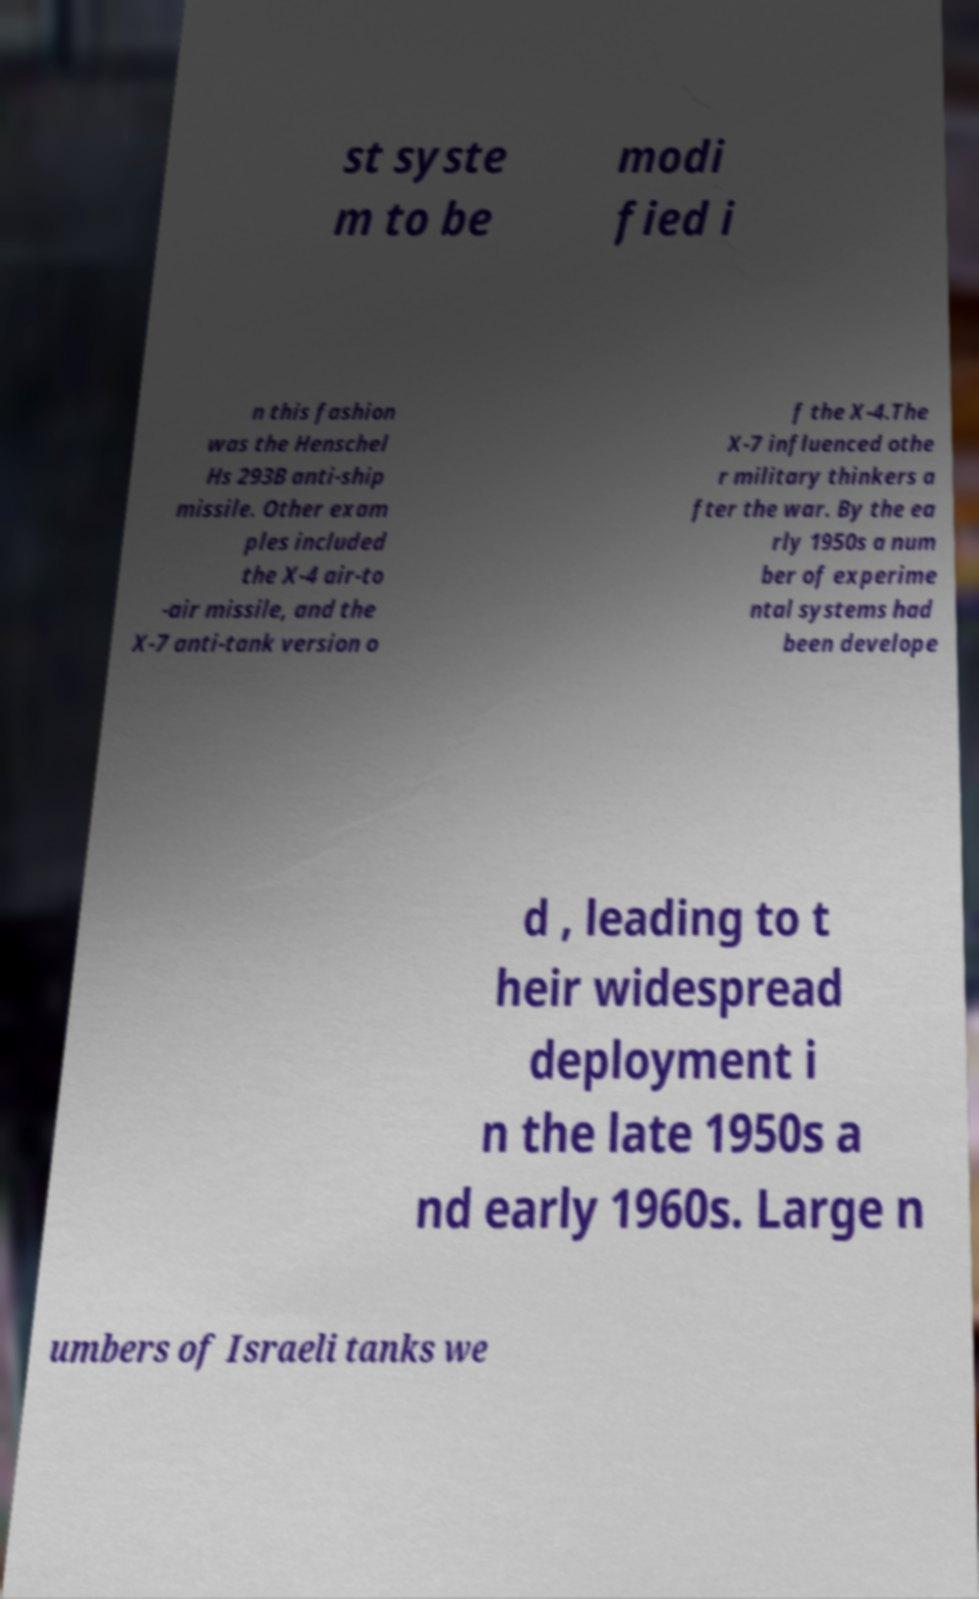Please identify and transcribe the text found in this image. st syste m to be modi fied i n this fashion was the Henschel Hs 293B anti-ship missile. Other exam ples included the X-4 air-to -air missile, and the X-7 anti-tank version o f the X-4.The X-7 influenced othe r military thinkers a fter the war. By the ea rly 1950s a num ber of experime ntal systems had been develope d , leading to t heir widespread deployment i n the late 1950s a nd early 1960s. Large n umbers of Israeli tanks we 